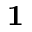<formula> <loc_0><loc_0><loc_500><loc_500>1</formula> 